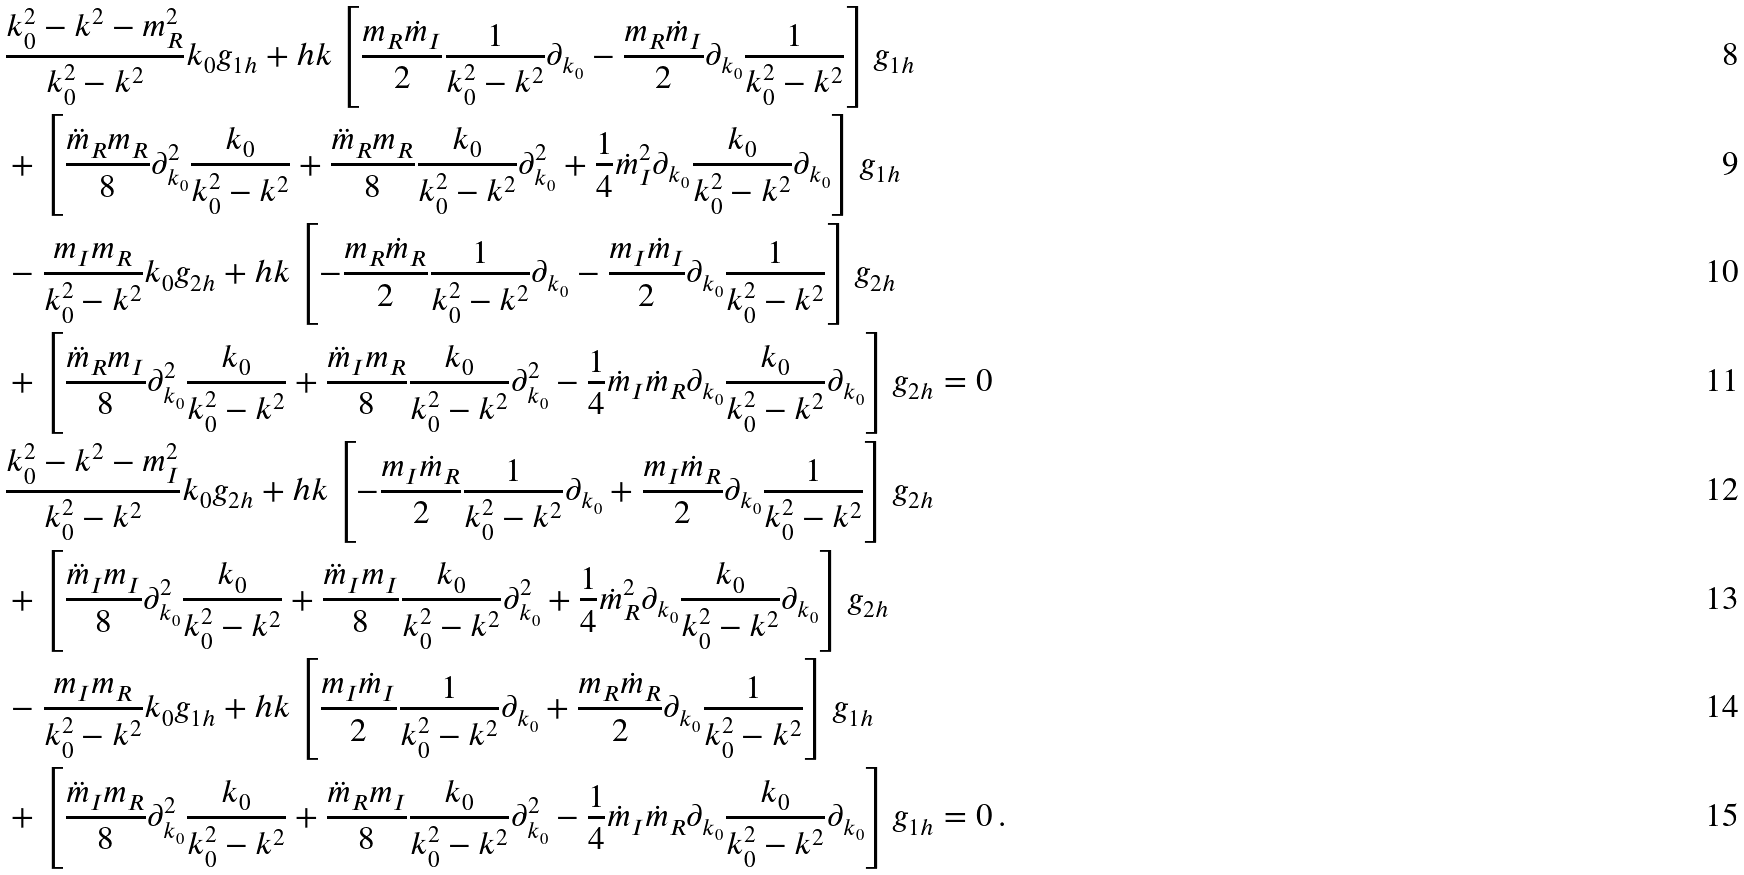<formula> <loc_0><loc_0><loc_500><loc_500>& \frac { k _ { 0 } ^ { 2 } - k ^ { 2 } - m _ { R } ^ { 2 } } { k _ { 0 } ^ { 2 } - k ^ { 2 } } k _ { 0 } g _ { 1 h } + h k \left [ \frac { m _ { R } \dot { m } _ { I } } { 2 } \frac { 1 } { k _ { 0 } ^ { 2 } - k ^ { 2 } } \partial _ { k _ { 0 } } - \frac { m _ { R } \dot { m } _ { I } } { 2 } \partial _ { k _ { 0 } } \frac { 1 } { k _ { 0 } ^ { 2 } - k ^ { 2 } } \right ] g _ { 1 h } \\ & + \left [ \frac { \ddot { m } _ { R } m _ { R } } { 8 } \partial _ { k _ { 0 } } ^ { 2 } \frac { k _ { 0 } } { k _ { 0 } ^ { 2 } - k ^ { 2 } } + \frac { \ddot { m } _ { R } m _ { R } } { 8 } \frac { k _ { 0 } } { k _ { 0 } ^ { 2 } - k ^ { 2 } } \partial _ { k _ { 0 } } ^ { 2 } + \frac { 1 } { 4 } \dot { m } _ { I } ^ { 2 } \partial _ { k _ { 0 } } \frac { k _ { 0 } } { k _ { 0 } ^ { 2 } - k ^ { 2 } } \partial _ { k _ { 0 } } \right ] g _ { 1 h } \\ & - \frac { m _ { I } m _ { R } } { k _ { 0 } ^ { 2 } - k ^ { 2 } } k _ { 0 } g _ { 2 h } + h k \left [ - \frac { m _ { R } \dot { m } _ { R } } { 2 } \frac { 1 } { k _ { 0 } ^ { 2 } - k ^ { 2 } } \partial _ { k _ { 0 } } - \frac { m _ { I } \dot { m } _ { I } } { 2 } \partial _ { k _ { 0 } } \frac { 1 } { k _ { 0 } ^ { 2 } - k ^ { 2 } } \right ] g _ { 2 h } \\ & + \left [ \frac { \ddot { m } _ { R } m _ { I } } { 8 } \partial _ { k _ { 0 } } ^ { 2 } \frac { k _ { 0 } } { k _ { 0 } ^ { 2 } - k ^ { 2 } } + \frac { \ddot { m } _ { I } m _ { R } } { 8 } \frac { k _ { 0 } } { k _ { 0 } ^ { 2 } - k ^ { 2 } } \partial _ { k _ { 0 } } ^ { 2 } - \frac { 1 } { 4 } \dot { m } _ { I } \dot { m } _ { R } \partial _ { k _ { 0 } } \frac { k _ { 0 } } { k _ { 0 } ^ { 2 } - k ^ { 2 } } \partial _ { k _ { 0 } } \right ] g _ { 2 h } = 0 \\ & \frac { k _ { 0 } ^ { 2 } - k ^ { 2 } - m _ { I } ^ { 2 } } { k _ { 0 } ^ { 2 } - k ^ { 2 } } k _ { 0 } g _ { 2 h } + h k \left [ - \frac { m _ { I } \dot { m } _ { R } } { 2 } \frac { 1 } { k _ { 0 } ^ { 2 } - k ^ { 2 } } \partial _ { k _ { 0 } } + \frac { m _ { I } \dot { m } _ { R } } { 2 } \partial _ { k _ { 0 } } \frac { 1 } { k _ { 0 } ^ { 2 } - k ^ { 2 } } \right ] g _ { 2 h } \\ & + \left [ \frac { \ddot { m } _ { I } m _ { I } } { 8 } \partial _ { k _ { 0 } } ^ { 2 } \frac { k _ { 0 } } { k _ { 0 } ^ { 2 } - k ^ { 2 } } + \frac { \ddot { m } _ { I } m _ { I } } { 8 } \frac { k _ { 0 } } { k _ { 0 } ^ { 2 } - k ^ { 2 } } \partial _ { k _ { 0 } } ^ { 2 } + \frac { 1 } { 4 } \dot { m } _ { R } ^ { 2 } \partial _ { k _ { 0 } } \frac { k _ { 0 } } { k _ { 0 } ^ { 2 } - k ^ { 2 } } \partial _ { k _ { 0 } } \right ] g _ { 2 h } \\ & - \frac { m _ { I } m _ { R } } { k _ { 0 } ^ { 2 } - k ^ { 2 } } k _ { 0 } g _ { 1 h } + h k \left [ \frac { m _ { I } \dot { m } _ { I } } { 2 } \frac { 1 } { k _ { 0 } ^ { 2 } - k ^ { 2 } } \partial _ { k _ { 0 } } + \frac { m _ { R } \dot { m } _ { R } } { 2 } \partial _ { k _ { 0 } } \frac { 1 } { k _ { 0 } ^ { 2 } - k ^ { 2 } } \right ] g _ { 1 h } \\ & + \left [ \frac { \ddot { m } _ { I } m _ { R } } { 8 } \partial _ { k _ { 0 } } ^ { 2 } \frac { k _ { 0 } } { k _ { 0 } ^ { 2 } - k ^ { 2 } } + \frac { \ddot { m } _ { R } m _ { I } } { 8 } \frac { k _ { 0 } } { k _ { 0 } ^ { 2 } - k ^ { 2 } } \partial _ { k _ { 0 } } ^ { 2 } - \frac { 1 } { 4 } \dot { m } _ { I } \dot { m } _ { R } \partial _ { k _ { 0 } } \frac { k _ { 0 } } { k _ { 0 } ^ { 2 } - k ^ { 2 } } \partial _ { k _ { 0 } } \right ] g _ { 1 h } = 0 \, .</formula> 